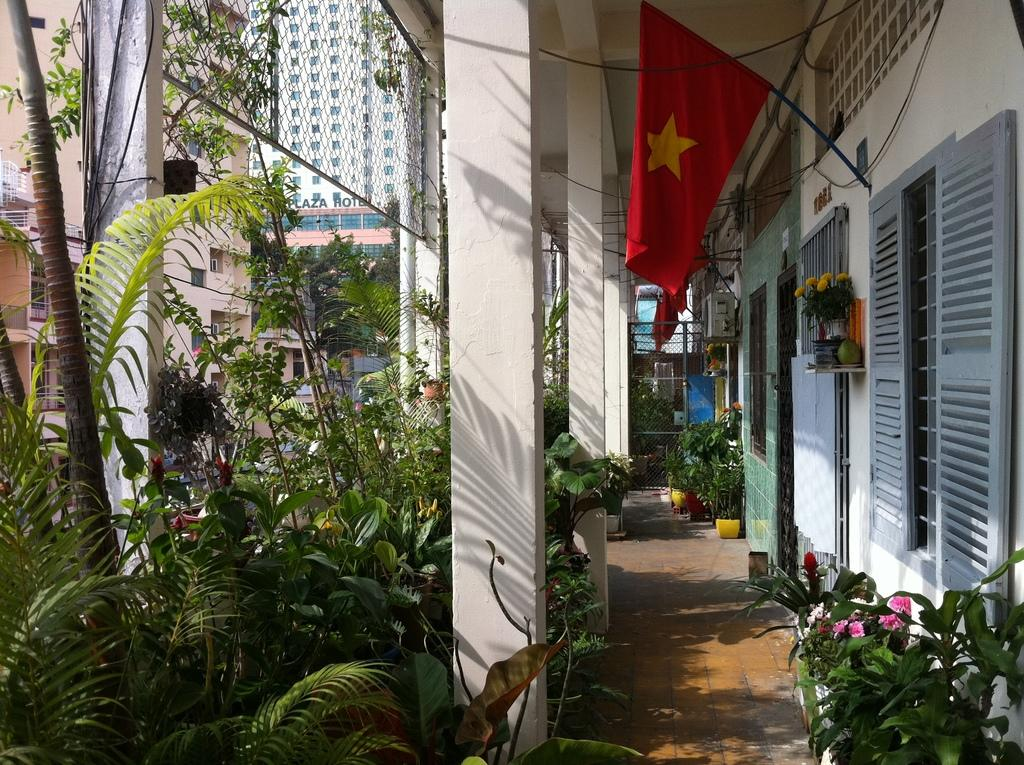What type of structures can be seen in the image? There are buildings in the image. What natural elements are present in the image? There are trees and plants in pots in the image. What type of flora is visible in the image? Flowers are visible in the image. What decorative or symbolic elements can be seen in the image? There are flags in the image. What architectural feature is present in the image? A metal fence, fixed to pillars, is present in the image. How many chairs are visible in the image? There are no chairs present in the image. What letters can be seen on the flags in the image? There is no information about letters on the flags in the image; only the presence of flags is mentioned. 